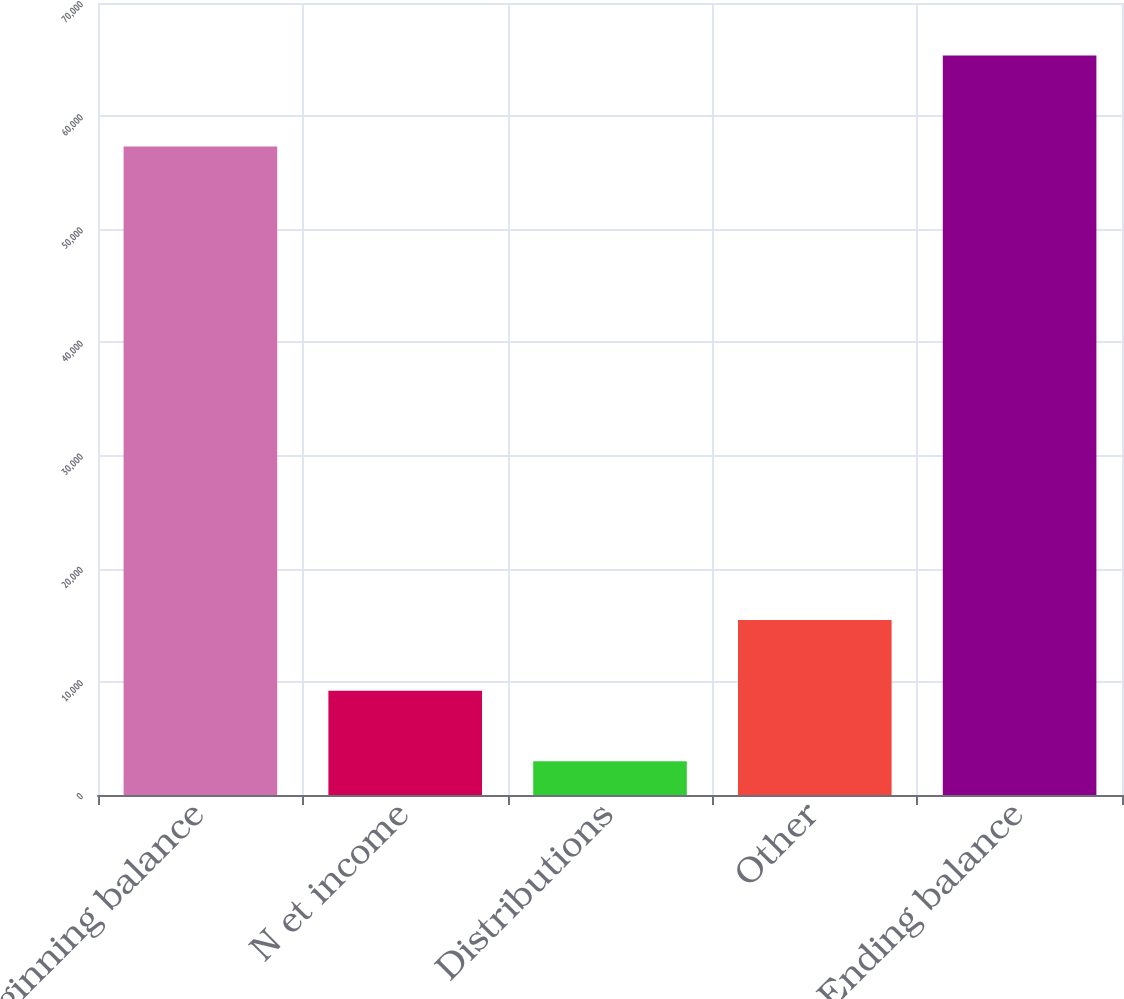Convert chart to OTSL. <chart><loc_0><loc_0><loc_500><loc_500><bar_chart><fcel>Beginning balance<fcel>N et income<fcel>Distributions<fcel>Other<fcel>Ending balance<nl><fcel>57325<fcel>9221.8<fcel>2984<fcel>15459.6<fcel>65362<nl></chart> 